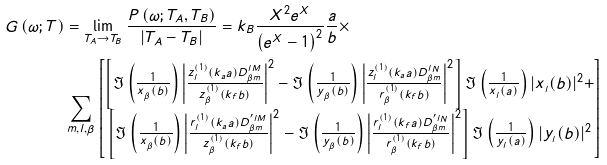Convert formula to latex. <formula><loc_0><loc_0><loc_500><loc_500>G \left ( \omega ; T \right ) & = \lim _ { T _ { A } \rightarrow T _ { B } } \frac { P \left ( \omega ; T _ { A } , T _ { B } \right ) } { | T _ { A } - T _ { B } | } = k _ { B } \frac { X ^ { 2 } e ^ { X } } { \left ( e ^ { X } - 1 \right ) ^ { 2 } } \frac { a } { b } \times \\ & \sum _ { m , l , \beta } \left [ \begin{matrix} \left [ \Im \left ( \frac { 1 } { x _ { _ { \beta } } ( b ) } \right ) \left | \frac { z ^ { ( 1 ) } _ { l } ( k _ { a } a ) D _ { \beta m } ^ { l M } } { z ^ { ( 1 ) } _ { \beta } ( k _ { f } b ) } \right | ^ { 2 } - \Im \left ( \frac { 1 } { y _ { _ { \beta } } ( b ) } \right ) \left | \frac { z ^ { ( 1 ) } _ { l } ( k _ { a } a ) D _ { \beta m } ^ { l N } } { r ^ { ( 1 ) } _ { \beta } ( k _ { f } b ) } \right | ^ { 2 } \right ] \Im \left ( \frac { 1 } { x _ { _ { l } } ( a ) } \right ) | x _ { _ { l } } ( b ) | ^ { 2 } + \\ \left [ \Im \left ( \frac { 1 } { x _ { _ { \beta } } ( b ) } \right ) \left | \frac { r ^ { ( 1 ) } _ { l } ( k _ { a } a ) D _ { \beta m } ^ { ^ { \prime } l M } } { z ^ { ( 1 ) } _ { \beta } ( k _ { f } b ) } \right | ^ { 2 } - \Im \left ( \frac { 1 } { y _ { _ { \beta } } ( b ) } \right ) \left | \frac { r ^ { ( 1 ) } _ { l } ( k _ { f } a ) D _ { \beta m } ^ { ^ { \prime } l N } } { r ^ { ( 1 ) } _ { \beta } ( k _ { f } b ) } \right | ^ { 2 } \right ] \Im \left ( \frac { 1 } { y _ { _ { l } } ( a ) } \right ) | y _ { _ { l } } ( b ) | ^ { 2 } \end{matrix} \right ]</formula> 